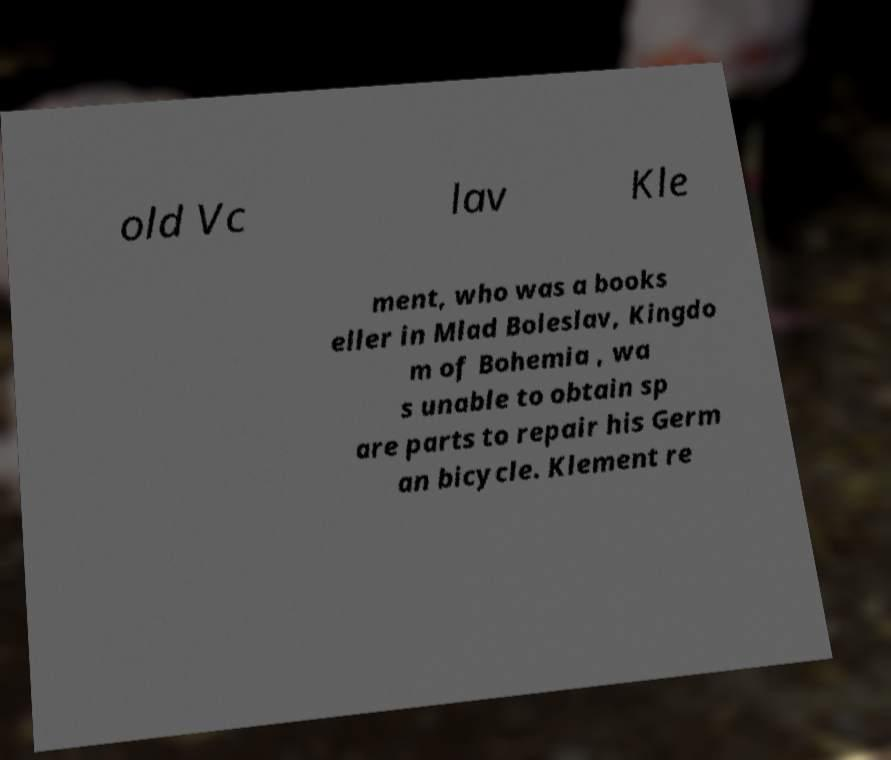Can you read and provide the text displayed in the image?This photo seems to have some interesting text. Can you extract and type it out for me? old Vc lav Kle ment, who was a books eller in Mlad Boleslav, Kingdo m of Bohemia , wa s unable to obtain sp are parts to repair his Germ an bicycle. Klement re 